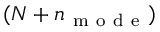<formula> <loc_0><loc_0><loc_500><loc_500>( N + n _ { m o d e } )</formula> 